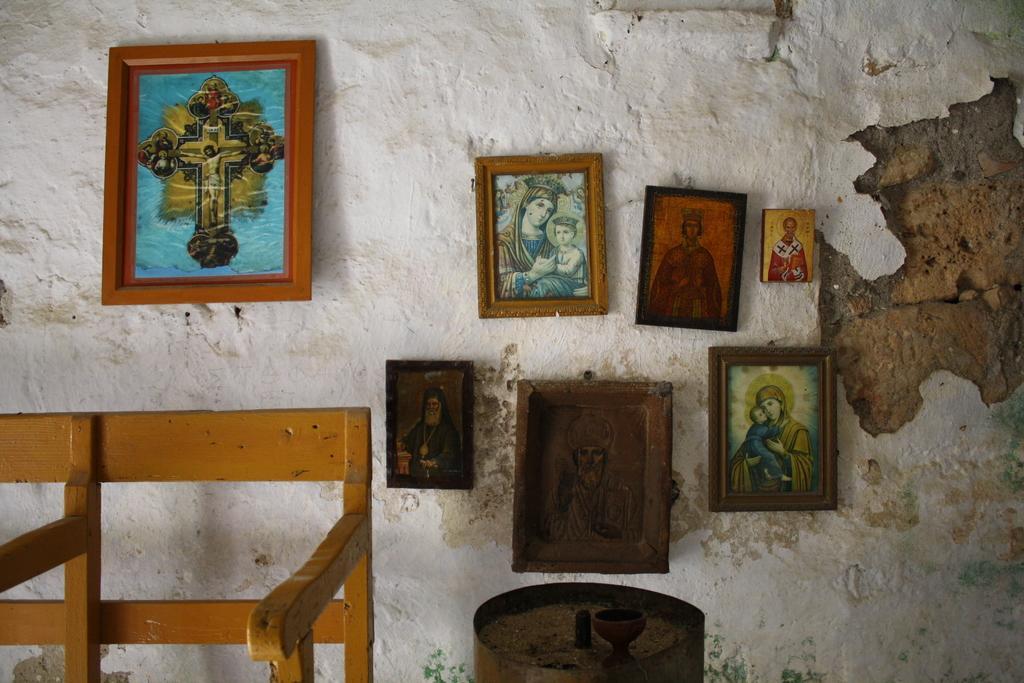How would you summarize this image in a sentence or two? In this picture I can see a bench, there is an object, there are frames attached to the wall. 